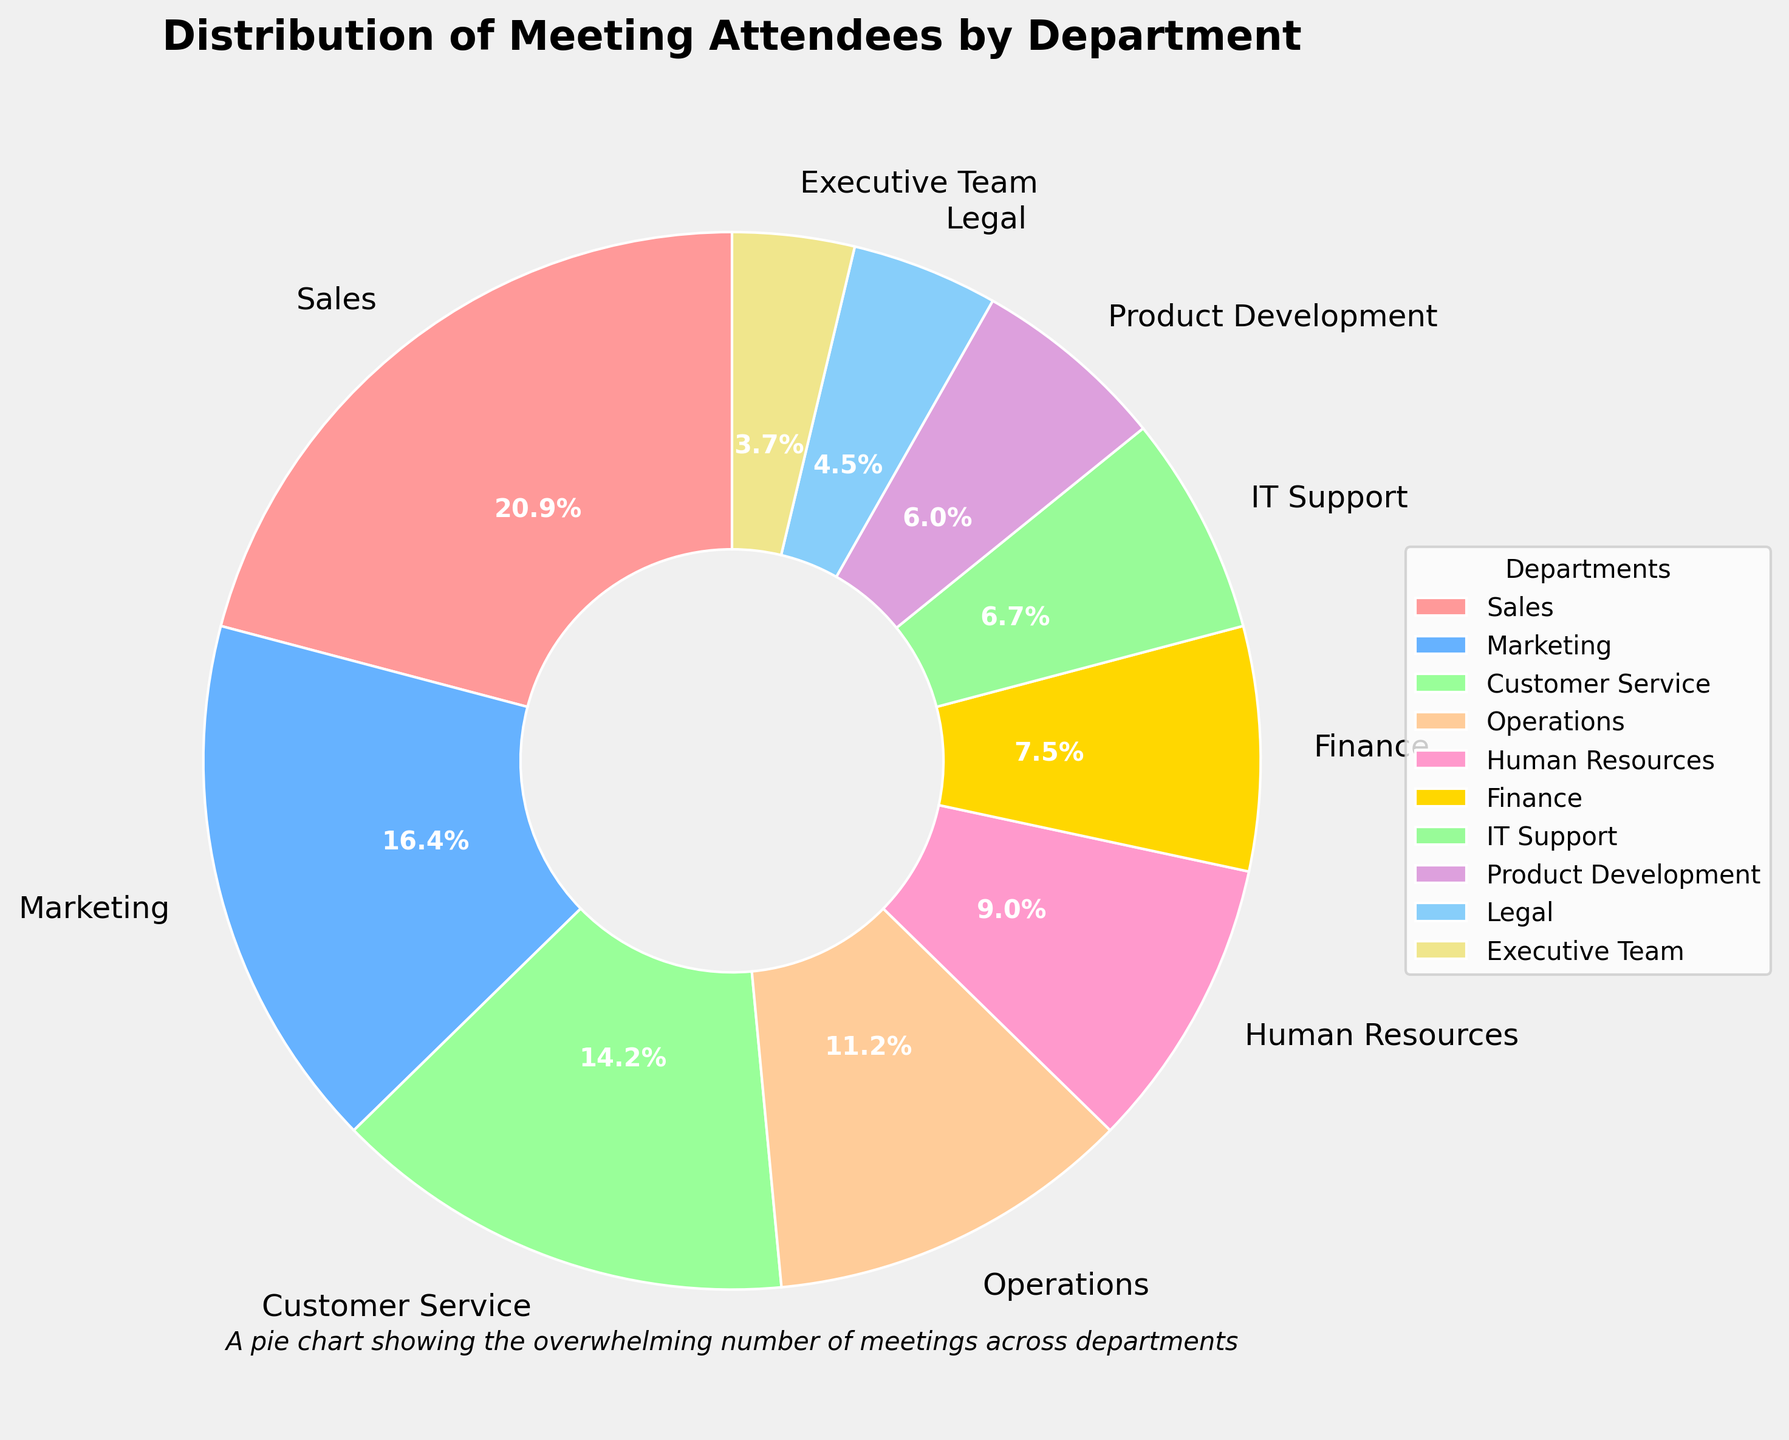Which department had the highest number of meeting attendees? To identify the department with the highest number of attendees, check the portion of the pie chart that is the largest. In this chart, the Sales department has the largest segment.
Answer: Sales Which departments had fewer than 10 attendees each? To determine which departments had fewer than 10 attendees, look at the portions of the pie chart labeled with attendees counts. The departments with counts less than 10 are IT Support, Product Development, Legal, and Executive Team.
Answer: IT Support, Product Development, Legal, Executive Team What is the combined percentage of attendees from the Operations and Finance departments? First, find the percentages for the Operations and Finance segments in the pie chart. Operations has 15 attendees and Finance has 10. Add their counts: 15 + 10 = 25. To find the combined percentage, perform this calculation: (25 / 134) * 100, where 134 is the total number of attendees (sum of all department attendees).
Answer: 18.7% Which department has more attendees, Marketing or Customer Service, and by how many? Locate the segments for Marketing and Customer Service. Marketing has 22 attendees and Customer Service has 19. Subtract the smaller number from the larger number: 22 - 19 = 3. Marketing has 3 more attendees.
Answer: Marketing has 3 more attendees Which two departments have the closest numbers of meeting attendees? To find the departments with the closest numbers of attendees, compare the attendee counts of all departments. Customer Service has 19 and Operations has 15, the difference is 4; however, the smallest difference is between HR (12) and Finance (10), which is only 2.
Answer: Human Resources and Finance Which department had the smallest represented group in meetings, and what percentage did they constitute? Identify the smallest segment in the pie chart. The Executive Team has the smallest segment. To find their percentage, divide their count by the total number of attendees and multiply by 100: (5 / 134) * 100 = 3.7%.
Answer: Executive Team, 3.7% How many more attendees are there in the Sales department compared to the Legal department? Find the attendee counts for Sales and Legal departments from the pie chart. Sales has 28 attendees, and Legal has 6. Subtract the number of Legal attendees from the Sales attendees: 28 - 6 = 22.
Answer: 22 What proportion of the entire meeting attendees represent the departments of IT Support and Product Development combined? Find the attendee counts for IT Support and Product Development. IT Support has 9 and Product Development has 8. Add these together to get 17. Calculate their proportion: 17 / 134.
Answer: 12.7% Which department has a larger share of attendees, Human Resources or Finance, and what is the visual indication? Compare the segments for Human Resources and Finance. Human Resources (12 attendees) is larger than Finance (10 attendees). The visual indication is the larger slice assigned to Human Resources.
Answer: Human Resources What is the average number of attendees per department? To find the average, divide the total number of attendees by the number of departments. Sum the attendees: 28 + 22 + 19 + 15 + 12 + 10 + 9 + 8 + 6 + 5 = 134. There are 10 departments, so the average is 134 / 10.
Answer: 13.4 